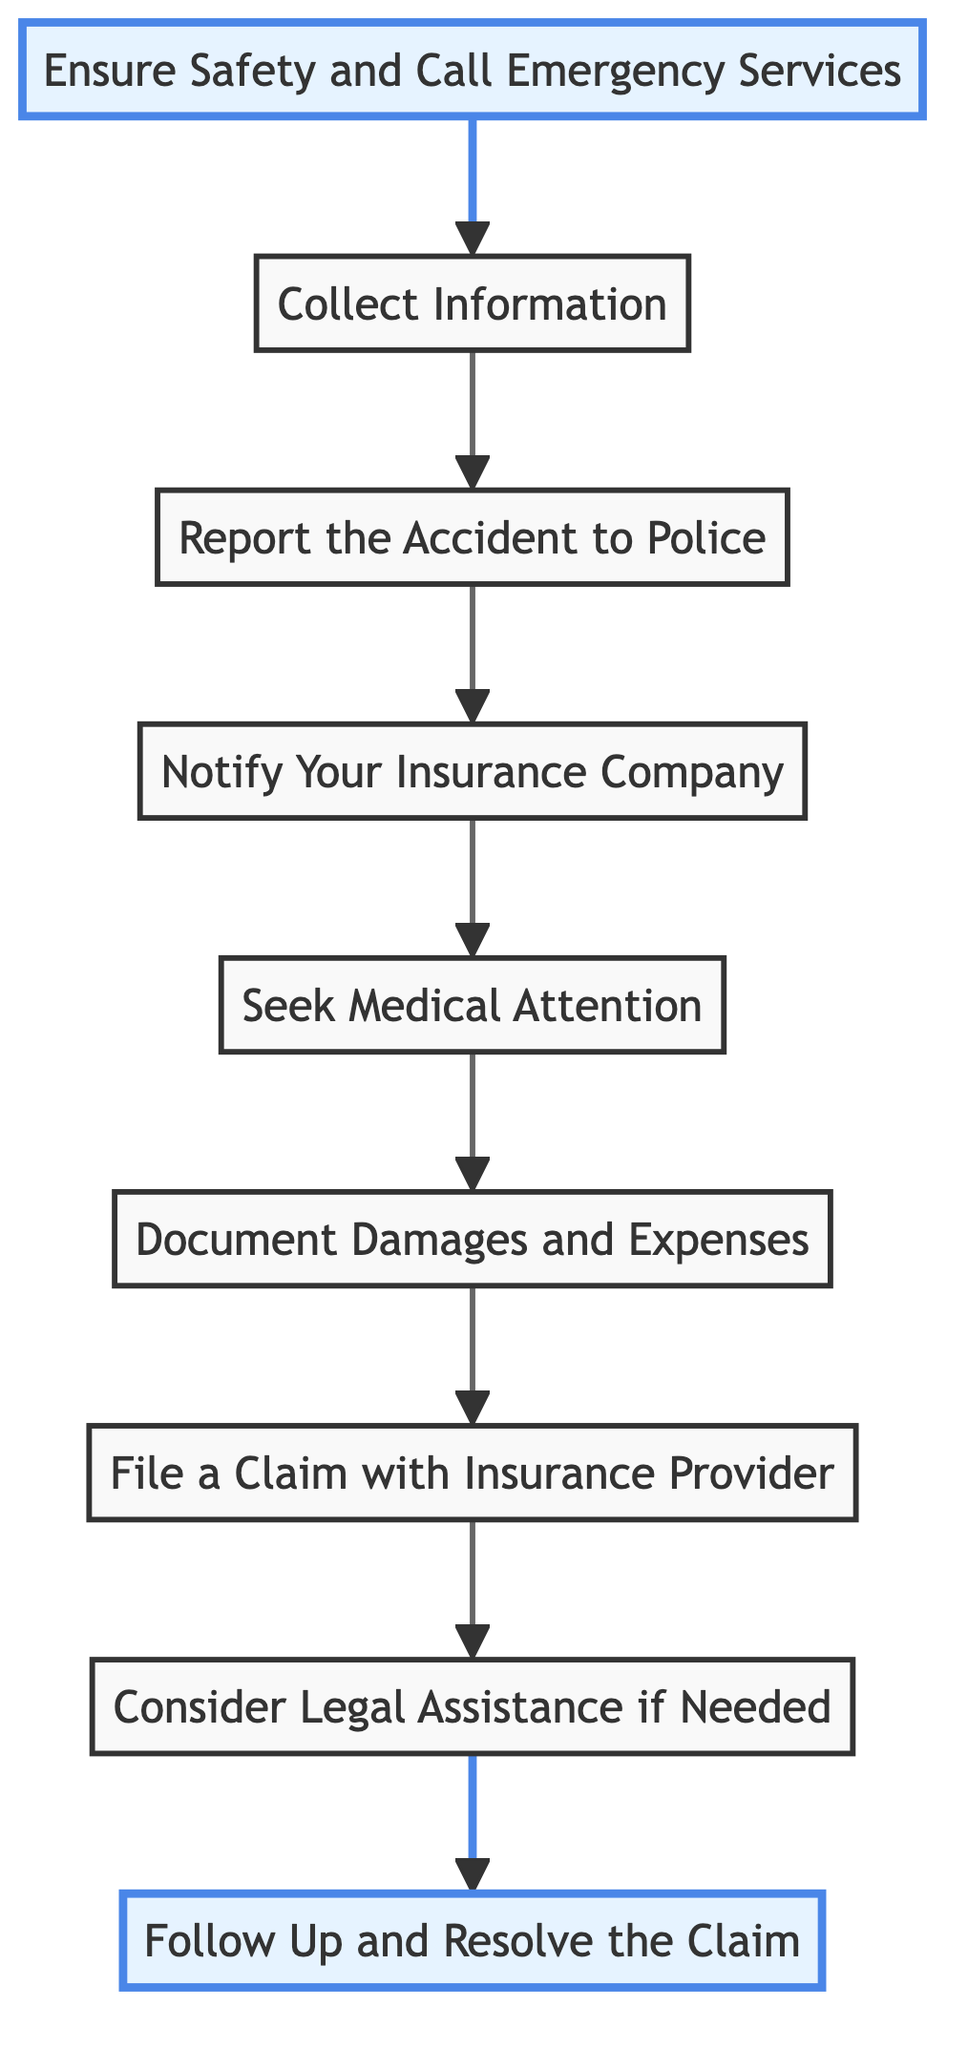What is the first step in the guide? The diagram indicates that the first step is labeled "Ensure Safety and Call Emergency Services."
Answer: Ensure Safety and Call Emergency Services How many steps are in the process? By counting the elements in the diagram, we find there are nine steps outlined in the guide.
Answer: Nine What follows after "Collect Information"? The diagram shows that "Report the Accident to Police" follows "Collect Information" in the flow of steps.
Answer: Report the Accident to Police What is the last step in the claim process? The final step indicated in the diagram is "Follow Up and Resolve the Claim."
Answer: Follow Up and Resolve the Claim Which step immediately follows notifying your insurance company? The diagram illustrates that "Seek Medical Attention" immediately follows the step of notifying the insurance company.
Answer: Seek Medical Attention If you have legal disputes, which step should you consider? Referring to the diagram, if legal disputes occur, the step to consider is "Consider Legal Assistance if Needed."
Answer: Consider Legal Assistance if Needed How are the first and last steps connected? The first step involves ensuring safety, and the last step is about following up on the claim; together, they encompass the entire process, ensuring safety and resolution.
Answer: Ensuring safety and resolution Which steps require documentation? The steps that require documentation, as shown in the flowchart, are "Collect Information," "Document Damages and Expenses," and "File a Claim with Insurance Provider."
Answer: Collect Information, Document Damages and Expenses, File a Claim with Insurance Provider 